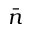<formula> <loc_0><loc_0><loc_500><loc_500>\bar { n }</formula> 